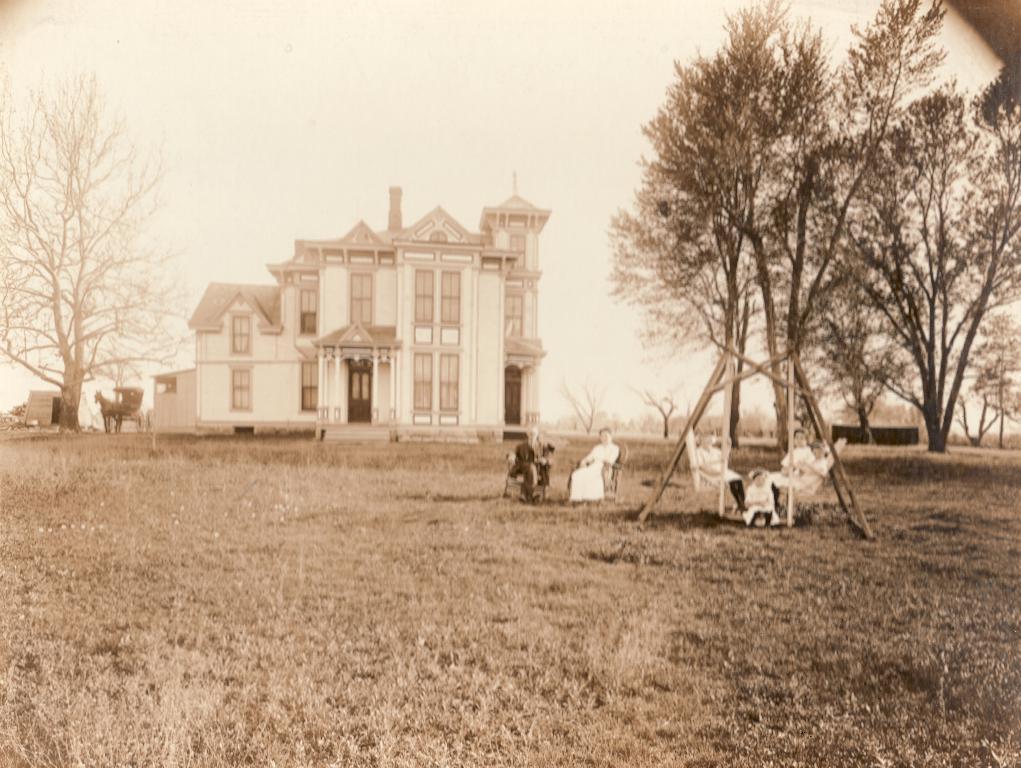In one or two sentences, can you explain what this image depicts? In this image I can see a building. There are trees, people, chairs and there is grass. In the background there is sky. 